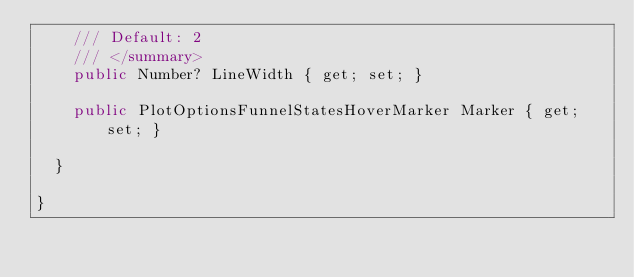<code> <loc_0><loc_0><loc_500><loc_500><_C#_>		/// Default: 2
		/// </summary>
		public Number? LineWidth { get; set; }

		public PlotOptionsFunnelStatesHoverMarker Marker { get; set; }

	}

}</code> 